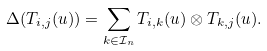Convert formula to latex. <formula><loc_0><loc_0><loc_500><loc_500>\Delta ( T _ { i , j } ( u ) ) = \sum _ { k \in \mathcal { I } _ { n } } T _ { i , k } ( u ) \otimes T _ { k , j } ( u ) .</formula> 